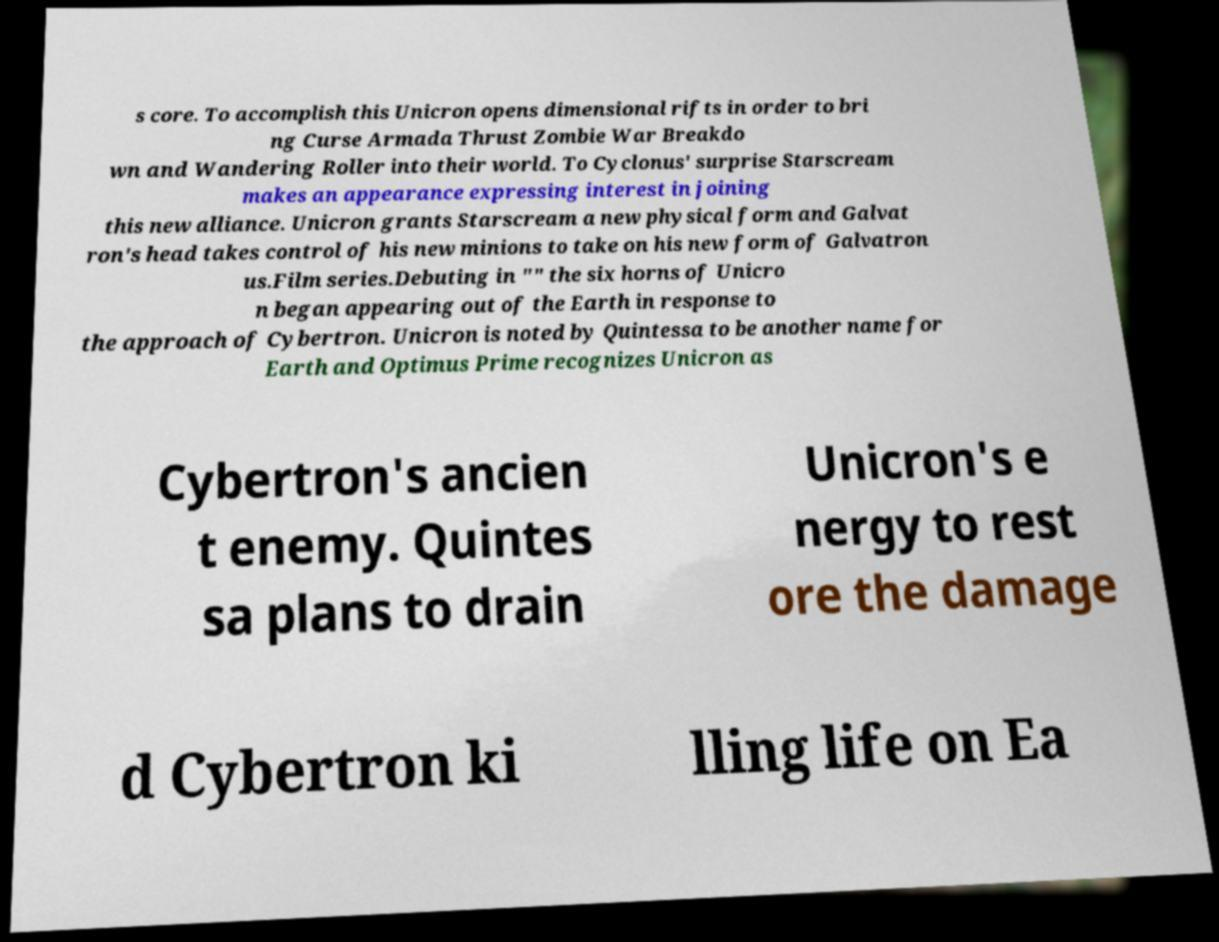Can you accurately transcribe the text from the provided image for me? s core. To accomplish this Unicron opens dimensional rifts in order to bri ng Curse Armada Thrust Zombie War Breakdo wn and Wandering Roller into their world. To Cyclonus' surprise Starscream makes an appearance expressing interest in joining this new alliance. Unicron grants Starscream a new physical form and Galvat ron's head takes control of his new minions to take on his new form of Galvatron us.Film series.Debuting in "" the six horns of Unicro n began appearing out of the Earth in response to the approach of Cybertron. Unicron is noted by Quintessa to be another name for Earth and Optimus Prime recognizes Unicron as Cybertron's ancien t enemy. Quintes sa plans to drain Unicron's e nergy to rest ore the damage d Cybertron ki lling life on Ea 